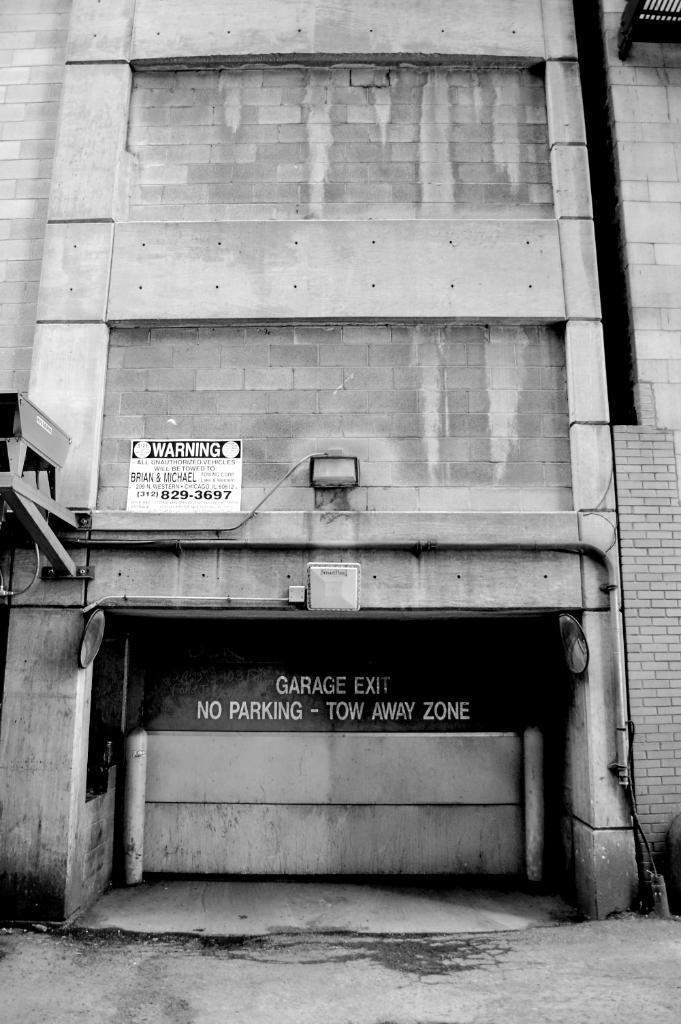What is the color scheme of the image? The image is black and white. What is the main structure in the image? There is a building in the image. What is attached to the building? There are boards on the building. What is written or displayed on the boards? There is text on the boards. What is visible at the bottom of the image? There is a road at the bottom of the image. What type of hair can be seen on the building in the image? There is no hair present on the building in the image. What kind of apparatus is used to power the building in the image? The image does not show any apparatus or power source for the building. 